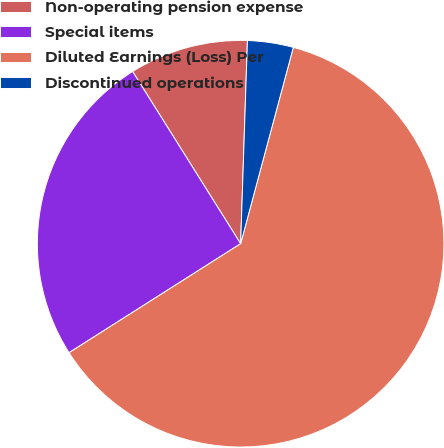Convert chart to OTSL. <chart><loc_0><loc_0><loc_500><loc_500><pie_chart><fcel>Non-operating pension expense<fcel>Special items<fcel>Diluted Earnings (Loss) Per<fcel>Discontinued operations<nl><fcel>9.45%<fcel>25.09%<fcel>61.82%<fcel>3.64%<nl></chart> 